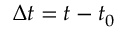Convert formula to latex. <formula><loc_0><loc_0><loc_500><loc_500>\Delta t = t - t _ { 0 }</formula> 